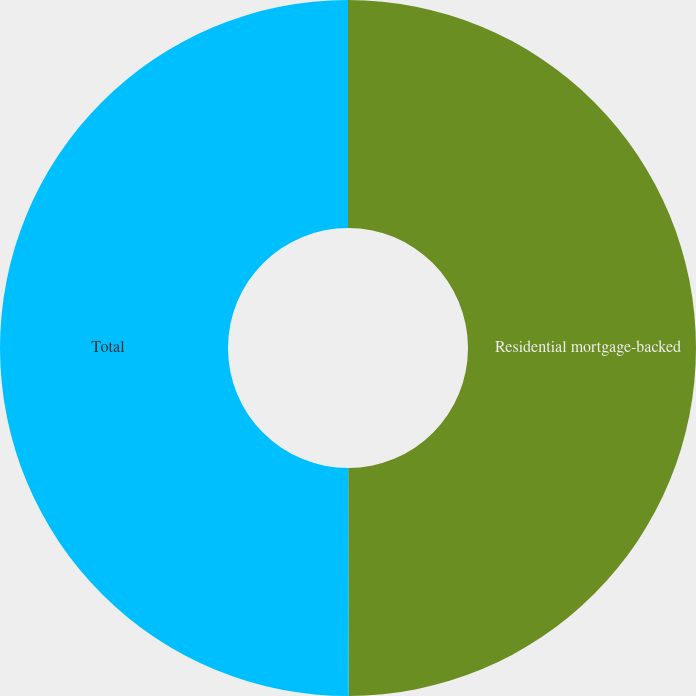Convert chart. <chart><loc_0><loc_0><loc_500><loc_500><pie_chart><fcel>Residential mortgage-backed<fcel>Total<nl><fcel>49.97%<fcel>50.03%<nl></chart> 